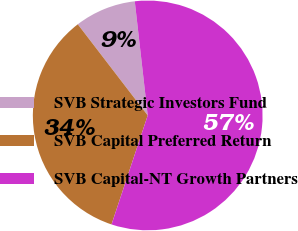Convert chart to OTSL. <chart><loc_0><loc_0><loc_500><loc_500><pie_chart><fcel>SVB Strategic Investors Fund<fcel>SVB Capital Preferred Return<fcel>SVB Capital-NT Growth Partners<nl><fcel>8.62%<fcel>34.48%<fcel>56.9%<nl></chart> 